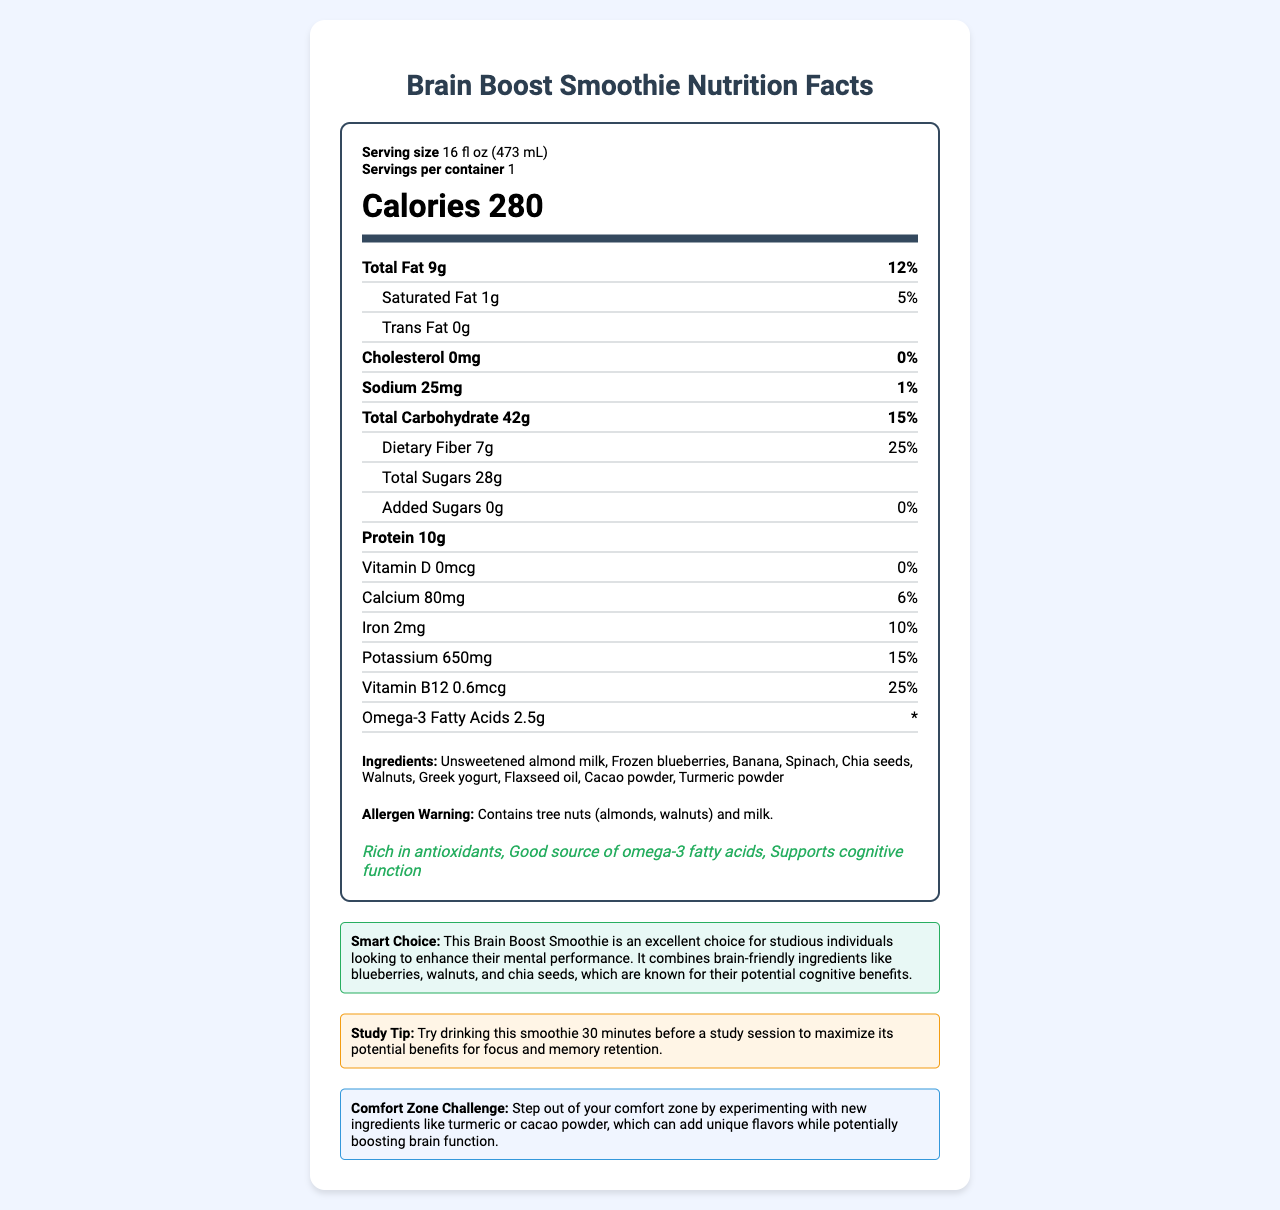what is the serving size? The serving size is listed at the top of the nutrition label under the "Serving size" section.
Answer: 16 fl oz (473 mL) how many calories are in one serving? The calories per serving are indicated in the "Calories" section of the nutrition label.
Answer: 280 what is the total amount of fat per serving? The total amount of fat per serving is specified in the "Total Fat" row.
Answer: 9g how many grams of protein are in the smoothie? The amount of protein is listed in the "Protein" row of the nutrition label.
Answer: 10g name three brain-boosting ingredients in the smoothie These ingredients are mentioned in the "Smart Choice" section, which highlights brain-friendly ingredients.
Answer: Blueberries, Walnuts, Chia seeds what percentage of daily value does dietary fiber provide? The percentage of daily value for dietary fiber is given in the "Dietary Fiber" sub-row.
Answer: 25% which ingredient is a source of vitamin B12? A. Almond milk B. Greek yogurt C. Walnuts Greek yogurt is commonly known to be a source of vitamin B12.
Answer: B what nutrients are represented with 0% of the daily value in this smoothie? A. Saturated Fat and Cholesterol B. Trans Fat and Vitamin D C. Cholesterol and Vitamin D Both Cholesterol and Vitamin D are listed with 0% of the daily value.
Answer: C is there any added sugar in the smoothie? The label indicates that there are 0g of added sugars.
Answer: No does the smoothie contain any allergens? The allergen warning section specifies that the smoothie contains tree nuts (almonds, walnuts) and milk.
Answer: Yes summarize the main idea of the document The document extensively details the nutritional benefits, components, and intended cognitive advantages of the Brain Boost Smoothie, while also providing suggestions for its optimal use and ingredient experimentation.
Answer: The document provides the nutrition facts for a Brain Boost Smoothie designed to enhance brain function and memory. It includes information about serving size, calorie content, nutrients, ingredients, allergen warnings, and health claims. The smoothie is rich in antioxidants, omega-3 fatty acids, and supports cognitive function. It also includes tips for maximizing study benefits and encourages stepping out of one's comfort zone by trying new ingredients. what is the purpose of the 'study tip'? The study tip section aims to help users utilize the smoothie in a way that enhances mental performance during study sessions.
Answer: To suggest drinking the smoothie 30 minutes before a study session to maximize benefits for focus and memory retention how much potassium does the smoothie contain? The amount of potassium is displayed in the "Potassium" row of the nutrition label.
Answer: 650mg is the document suggesting that the smoothie is good for mental performance? The Smart Choice section mentions that the smoothie is an excellent choice for enhancing mental performance due to its brain-friendly ingredients.
Answer: Yes how many ingredients are listed in the smoothie? The number of ingredients can be counted from the ingredients list, which includes Unsweetened almond milk, Frozen blueberries, Banana, Spinach, Chia seeds, Walnuts, Greek yogurt, Flaxseed oil, Cacao powder, and Turmeric powder.
Answer: 10 what is the average percentage daily value of calcium provided by this smoothie? The document provides the daily value percentage for calcium as 6%, but without other data points or an average calculation context, the average cannot be determined based solely on the visual information in the document.
Answer: Can't be determined from the given information 